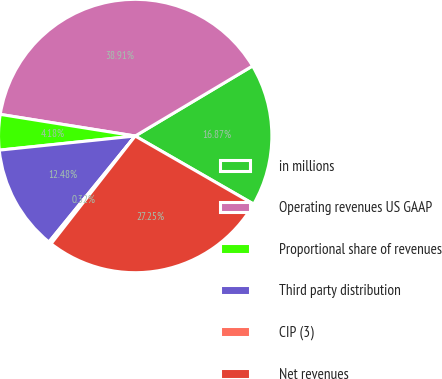Convert chart. <chart><loc_0><loc_0><loc_500><loc_500><pie_chart><fcel>in millions<fcel>Operating revenues US GAAP<fcel>Proportional share of revenues<fcel>Third party distribution<fcel>CIP (3)<fcel>Net revenues<nl><fcel>16.87%<fcel>38.91%<fcel>4.18%<fcel>12.48%<fcel>0.32%<fcel>27.25%<nl></chart> 